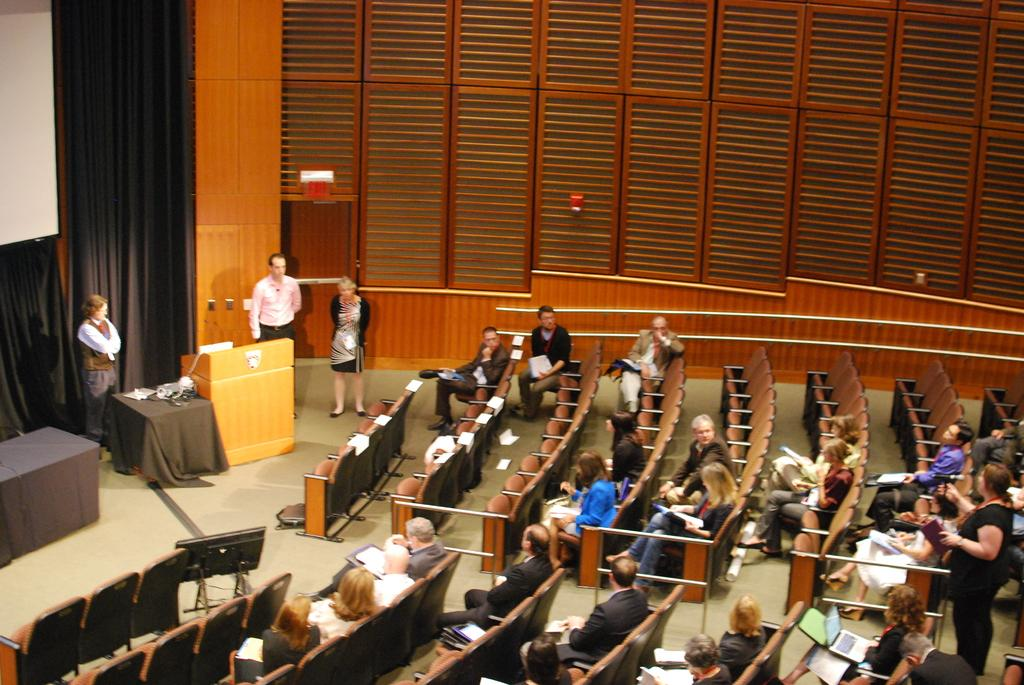What are the people in the image doing? The people in the image are sitting in chairs. How many people are standing in the image? There are three people standing in the image. What can be seen hanging in the background of the image? There is a curtain in the image. Where is the table located in the image? The table is on the left side of the image. Can you see any fairies writing on the string in the image? There are no fairies or strings present in the image. 